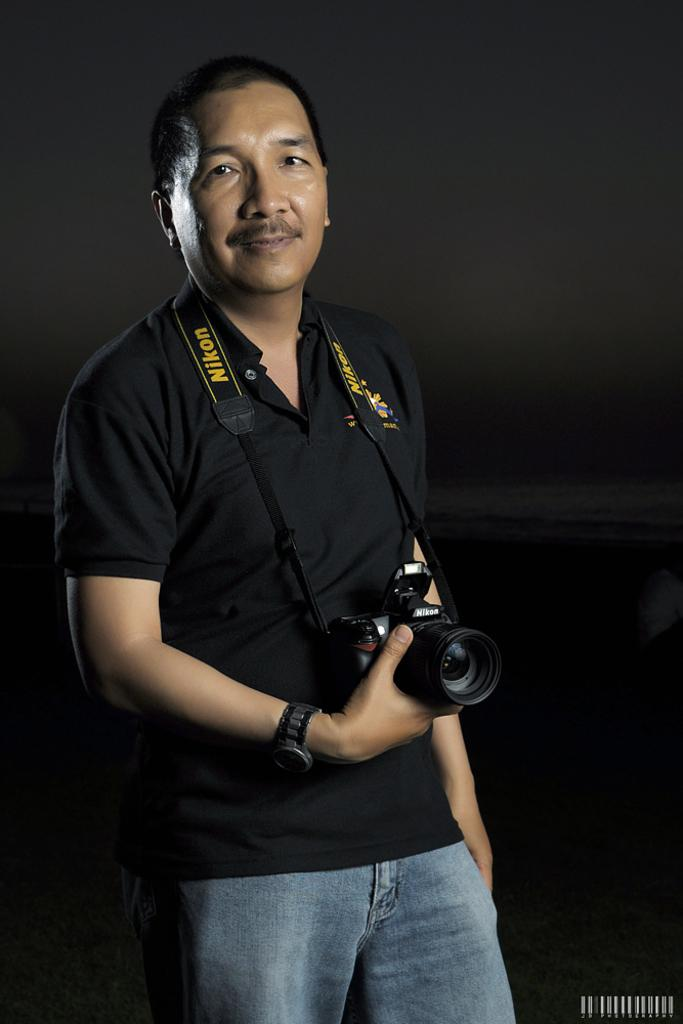What is the main subject of the image? The main subject of the image is a man. What is the man holding in his hand? The man is holding a camera in his hand. What type of ticket is the man holding in his hand? The man is not holding a ticket in his hand; he is holding a camera. How many wings can be seen on the man in the image? There are no wings visible on the man in the image. 